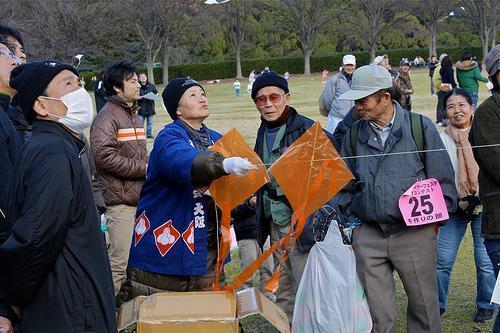How many people are wearing surgical masks?
Give a very brief answer. 1. How many people are wearing hats?
Give a very brief answer. 8. How many people are there?
Give a very brief answer. 9. How many kites are there?
Give a very brief answer. 2. 